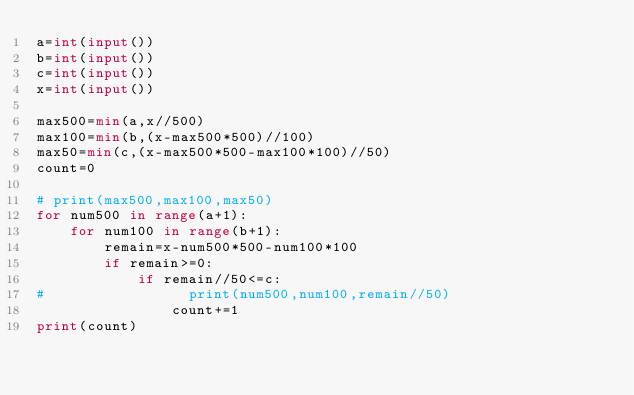<code> <loc_0><loc_0><loc_500><loc_500><_Python_>a=int(input())
b=int(input())
c=int(input())
x=int(input())

max500=min(a,x//500)
max100=min(b,(x-max500*500)//100)
max50=min(c,(x-max500*500-max100*100)//50)
count=0

# print(max500,max100,max50)
for num500 in range(a+1):
    for num100 in range(b+1):
        remain=x-num500*500-num100*100
        if remain>=0:
            if remain//50<=c:
#                 print(num500,num100,remain//50)
                count+=1
print(count)</code> 